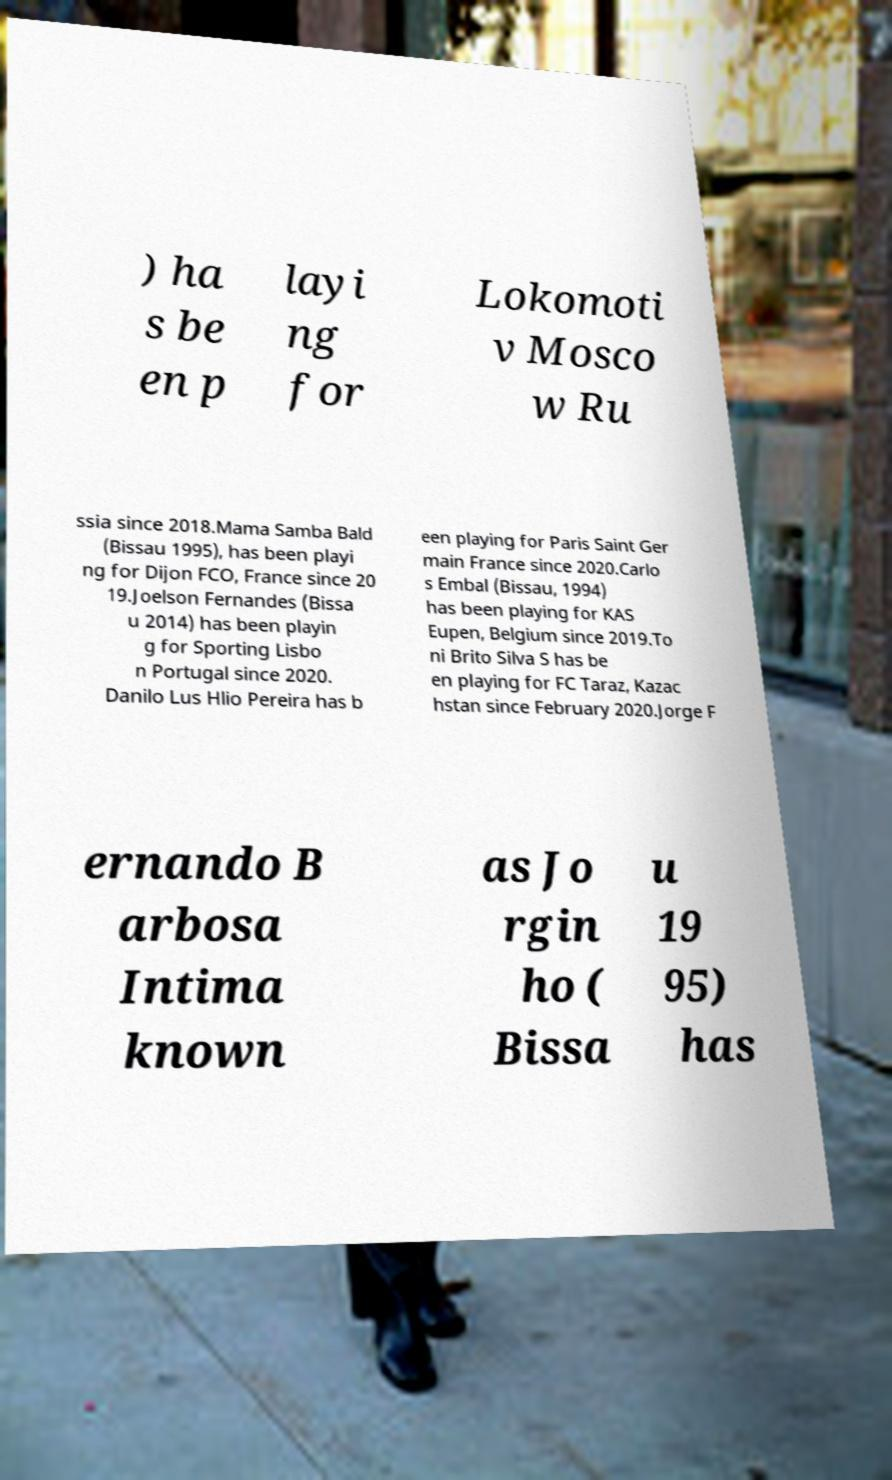Please identify and transcribe the text found in this image. ) ha s be en p layi ng for Lokomoti v Mosco w Ru ssia since 2018.Mama Samba Bald (Bissau 1995), has been playi ng for Dijon FCO, France since 20 19.Joelson Fernandes (Bissa u 2014) has been playin g for Sporting Lisbo n Portugal since 2020. Danilo Lus Hlio Pereira has b een playing for Paris Saint Ger main France since 2020.Carlo s Embal (Bissau, 1994) has been playing for KAS Eupen, Belgium since 2019.To ni Brito Silva S has be en playing for FC Taraz, Kazac hstan since February 2020.Jorge F ernando B arbosa Intima known as Jo rgin ho ( Bissa u 19 95) has 